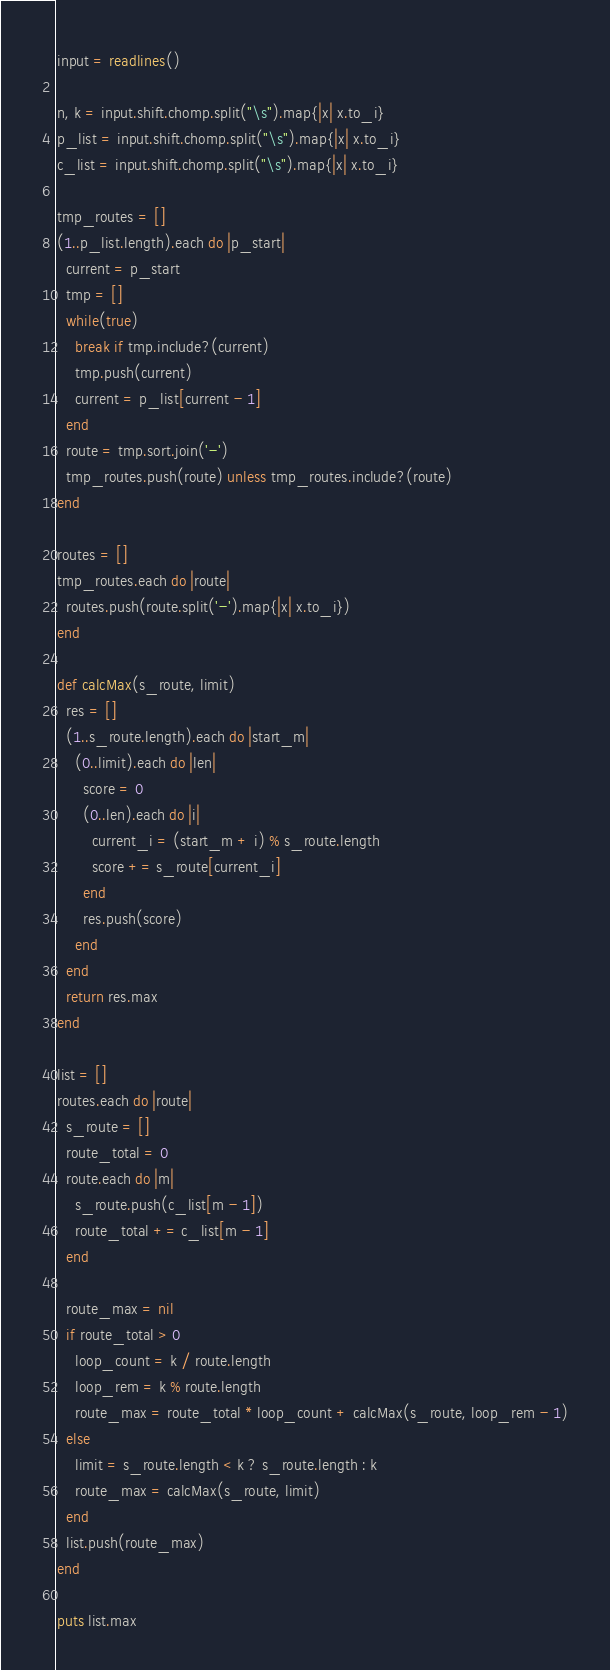Convert code to text. <code><loc_0><loc_0><loc_500><loc_500><_Ruby_>input = readlines()

n, k = input.shift.chomp.split("\s").map{|x| x.to_i}
p_list = input.shift.chomp.split("\s").map{|x| x.to_i}
c_list = input.shift.chomp.split("\s").map{|x| x.to_i}

tmp_routes = []
(1..p_list.length).each do |p_start|
  current = p_start
  tmp = []
  while(true)
    break if tmp.include?(current)
    tmp.push(current)
    current = p_list[current - 1]
  end
  route = tmp.sort.join('-')
  tmp_routes.push(route) unless tmp_routes.include?(route)
end

routes = []
tmp_routes.each do |route|
  routes.push(route.split('-').map{|x| x.to_i})
end

def calcMax(s_route, limit)
  res = []
  (1..s_route.length).each do |start_m|
    (0..limit).each do |len|
      score = 0
      (0..len).each do |i|
        current_i = (start_m + i) % s_route.length
        score += s_route[current_i]
      end
      res.push(score)
    end
  end
  return res.max
end

list = []
routes.each do |route|
  s_route = []
  route_total = 0
  route.each do |m|
    s_route.push(c_list[m - 1])
    route_total += c_list[m - 1]
  end

  route_max = nil
  if route_total > 0
    loop_count = k / route.length
    loop_rem = k % route.length
    route_max = route_total * loop_count + calcMax(s_route, loop_rem - 1)
  else
    limit = s_route.length < k ? s_route.length : k
    route_max = calcMax(s_route, limit)
  end
  list.push(route_max)
end

puts list.max
</code> 